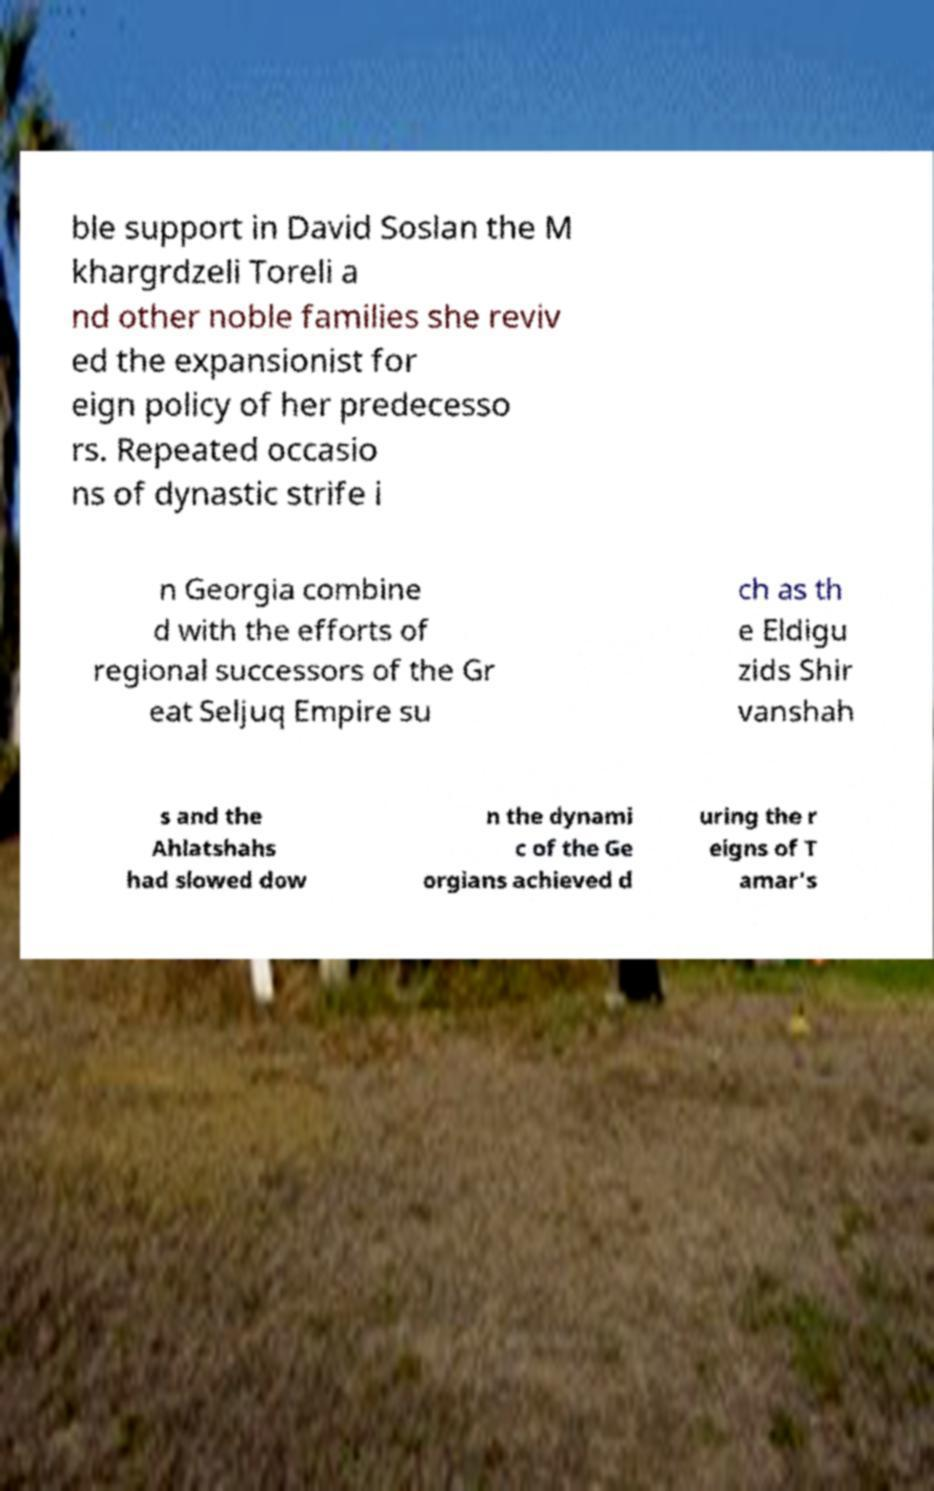For documentation purposes, I need the text within this image transcribed. Could you provide that? ble support in David Soslan the M khargrdzeli Toreli a nd other noble families she reviv ed the expansionist for eign policy of her predecesso rs. Repeated occasio ns of dynastic strife i n Georgia combine d with the efforts of regional successors of the Gr eat Seljuq Empire su ch as th e Eldigu zids Shir vanshah s and the Ahlatshahs had slowed dow n the dynami c of the Ge orgians achieved d uring the r eigns of T amar's 